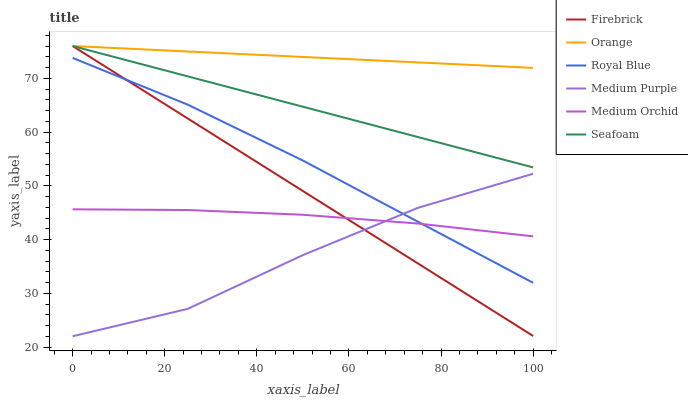Does Medium Purple have the minimum area under the curve?
Answer yes or no. Yes. Does Orange have the maximum area under the curve?
Answer yes or no. Yes. Does Medium Orchid have the minimum area under the curve?
Answer yes or no. No. Does Medium Orchid have the maximum area under the curve?
Answer yes or no. No. Is Seafoam the smoothest?
Answer yes or no. Yes. Is Medium Purple the roughest?
Answer yes or no. Yes. Is Medium Orchid the smoothest?
Answer yes or no. No. Is Medium Orchid the roughest?
Answer yes or no. No. Does Medium Orchid have the lowest value?
Answer yes or no. No. Does Orange have the highest value?
Answer yes or no. Yes. Does Medium Orchid have the highest value?
Answer yes or no. No. Is Medium Purple less than Orange?
Answer yes or no. Yes. Is Seafoam greater than Medium Orchid?
Answer yes or no. Yes. Does Firebrick intersect Orange?
Answer yes or no. Yes. Is Firebrick less than Orange?
Answer yes or no. No. Is Firebrick greater than Orange?
Answer yes or no. No. Does Medium Purple intersect Orange?
Answer yes or no. No. 